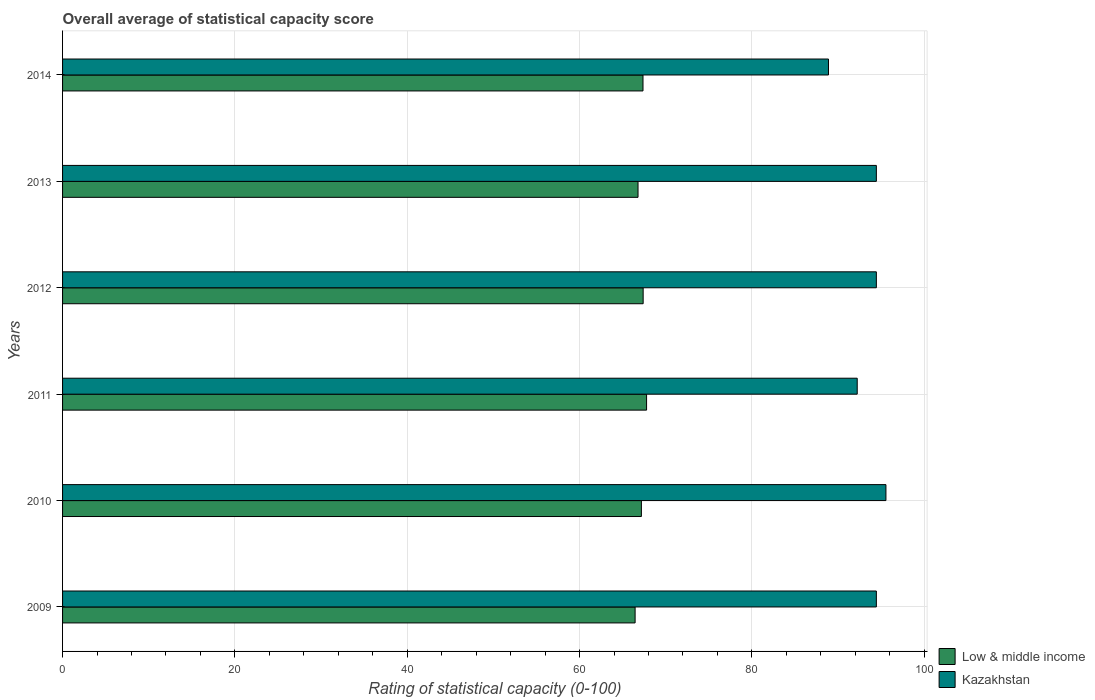How many different coloured bars are there?
Offer a terse response. 2. Are the number of bars per tick equal to the number of legend labels?
Give a very brief answer. Yes. Are the number of bars on each tick of the Y-axis equal?
Provide a succinct answer. Yes. How many bars are there on the 3rd tick from the top?
Ensure brevity in your answer.  2. How many bars are there on the 1st tick from the bottom?
Provide a succinct answer. 2. What is the label of the 2nd group of bars from the top?
Your response must be concise. 2013. In how many cases, is the number of bars for a given year not equal to the number of legend labels?
Give a very brief answer. 0. What is the rating of statistical capacity in Kazakhstan in 2014?
Ensure brevity in your answer.  88.89. Across all years, what is the maximum rating of statistical capacity in Low & middle income?
Make the answer very short. 67.78. Across all years, what is the minimum rating of statistical capacity in Kazakhstan?
Provide a short and direct response. 88.89. In which year was the rating of statistical capacity in Kazakhstan maximum?
Your answer should be compact. 2010. In which year was the rating of statistical capacity in Kazakhstan minimum?
Offer a terse response. 2014. What is the total rating of statistical capacity in Kazakhstan in the graph?
Make the answer very short. 560. What is the difference between the rating of statistical capacity in Kazakhstan in 2013 and that in 2014?
Offer a very short reply. 5.56. What is the difference between the rating of statistical capacity in Low & middle income in 2010 and the rating of statistical capacity in Kazakhstan in 2014?
Your answer should be compact. -21.71. What is the average rating of statistical capacity in Low & middle income per year?
Offer a terse response. 67.15. In the year 2009, what is the difference between the rating of statistical capacity in Low & middle income and rating of statistical capacity in Kazakhstan?
Give a very brief answer. -28. In how many years, is the rating of statistical capacity in Kazakhstan greater than 88 ?
Provide a succinct answer. 6. What is the ratio of the rating of statistical capacity in Low & middle income in 2011 to that in 2012?
Give a very brief answer. 1.01. Is the rating of statistical capacity in Kazakhstan in 2010 less than that in 2014?
Your answer should be compact. No. What is the difference between the highest and the second highest rating of statistical capacity in Low & middle income?
Keep it short and to the point. 0.4. What is the difference between the highest and the lowest rating of statistical capacity in Low & middle income?
Ensure brevity in your answer.  1.33. How many years are there in the graph?
Offer a very short reply. 6. What is the difference between two consecutive major ticks on the X-axis?
Your answer should be very brief. 20. Are the values on the major ticks of X-axis written in scientific E-notation?
Provide a short and direct response. No. Does the graph contain any zero values?
Ensure brevity in your answer.  No. Does the graph contain grids?
Ensure brevity in your answer.  Yes. How many legend labels are there?
Offer a very short reply. 2. What is the title of the graph?
Keep it short and to the point. Overall average of statistical capacity score. Does "China" appear as one of the legend labels in the graph?
Your answer should be compact. No. What is the label or title of the X-axis?
Your answer should be very brief. Rating of statistical capacity (0-100). What is the label or title of the Y-axis?
Offer a terse response. Years. What is the Rating of statistical capacity (0-100) in Low & middle income in 2009?
Your answer should be compact. 66.45. What is the Rating of statistical capacity (0-100) in Kazakhstan in 2009?
Offer a terse response. 94.44. What is the Rating of statistical capacity (0-100) of Low & middle income in 2010?
Your answer should be very brief. 67.18. What is the Rating of statistical capacity (0-100) of Kazakhstan in 2010?
Offer a terse response. 95.56. What is the Rating of statistical capacity (0-100) in Low & middle income in 2011?
Provide a succinct answer. 67.78. What is the Rating of statistical capacity (0-100) in Kazakhstan in 2011?
Offer a terse response. 92.22. What is the Rating of statistical capacity (0-100) of Low & middle income in 2012?
Your answer should be compact. 67.38. What is the Rating of statistical capacity (0-100) in Kazakhstan in 2012?
Your response must be concise. 94.44. What is the Rating of statistical capacity (0-100) in Low & middle income in 2013?
Offer a very short reply. 66.78. What is the Rating of statistical capacity (0-100) of Kazakhstan in 2013?
Your response must be concise. 94.44. What is the Rating of statistical capacity (0-100) in Low & middle income in 2014?
Keep it short and to the point. 67.36. What is the Rating of statistical capacity (0-100) of Kazakhstan in 2014?
Provide a short and direct response. 88.89. Across all years, what is the maximum Rating of statistical capacity (0-100) of Low & middle income?
Keep it short and to the point. 67.78. Across all years, what is the maximum Rating of statistical capacity (0-100) of Kazakhstan?
Make the answer very short. 95.56. Across all years, what is the minimum Rating of statistical capacity (0-100) of Low & middle income?
Keep it short and to the point. 66.45. Across all years, what is the minimum Rating of statistical capacity (0-100) in Kazakhstan?
Provide a succinct answer. 88.89. What is the total Rating of statistical capacity (0-100) in Low & middle income in the graph?
Ensure brevity in your answer.  402.93. What is the total Rating of statistical capacity (0-100) in Kazakhstan in the graph?
Ensure brevity in your answer.  560. What is the difference between the Rating of statistical capacity (0-100) in Low & middle income in 2009 and that in 2010?
Give a very brief answer. -0.73. What is the difference between the Rating of statistical capacity (0-100) in Kazakhstan in 2009 and that in 2010?
Ensure brevity in your answer.  -1.11. What is the difference between the Rating of statistical capacity (0-100) of Low & middle income in 2009 and that in 2011?
Provide a succinct answer. -1.33. What is the difference between the Rating of statistical capacity (0-100) of Kazakhstan in 2009 and that in 2011?
Give a very brief answer. 2.22. What is the difference between the Rating of statistical capacity (0-100) of Low & middle income in 2009 and that in 2012?
Provide a succinct answer. -0.93. What is the difference between the Rating of statistical capacity (0-100) of Kazakhstan in 2009 and that in 2012?
Give a very brief answer. 0. What is the difference between the Rating of statistical capacity (0-100) in Low & middle income in 2009 and that in 2013?
Provide a short and direct response. -0.34. What is the difference between the Rating of statistical capacity (0-100) in Kazakhstan in 2009 and that in 2013?
Make the answer very short. 0. What is the difference between the Rating of statistical capacity (0-100) in Low & middle income in 2009 and that in 2014?
Your answer should be compact. -0.92. What is the difference between the Rating of statistical capacity (0-100) of Kazakhstan in 2009 and that in 2014?
Give a very brief answer. 5.56. What is the difference between the Rating of statistical capacity (0-100) of Low & middle income in 2010 and that in 2011?
Offer a terse response. -0.6. What is the difference between the Rating of statistical capacity (0-100) of Kazakhstan in 2010 and that in 2011?
Your answer should be very brief. 3.33. What is the difference between the Rating of statistical capacity (0-100) of Low & middle income in 2010 and that in 2012?
Your response must be concise. -0.2. What is the difference between the Rating of statistical capacity (0-100) of Low & middle income in 2010 and that in 2013?
Give a very brief answer. 0.39. What is the difference between the Rating of statistical capacity (0-100) of Low & middle income in 2010 and that in 2014?
Offer a very short reply. -0.19. What is the difference between the Rating of statistical capacity (0-100) of Low & middle income in 2011 and that in 2012?
Your answer should be very brief. 0.4. What is the difference between the Rating of statistical capacity (0-100) in Kazakhstan in 2011 and that in 2012?
Offer a terse response. -2.22. What is the difference between the Rating of statistical capacity (0-100) of Low & middle income in 2011 and that in 2013?
Make the answer very short. 0.99. What is the difference between the Rating of statistical capacity (0-100) of Kazakhstan in 2011 and that in 2013?
Your response must be concise. -2.22. What is the difference between the Rating of statistical capacity (0-100) of Low & middle income in 2011 and that in 2014?
Offer a very short reply. 0.42. What is the difference between the Rating of statistical capacity (0-100) of Low & middle income in 2012 and that in 2013?
Ensure brevity in your answer.  0.59. What is the difference between the Rating of statistical capacity (0-100) in Kazakhstan in 2012 and that in 2013?
Your response must be concise. 0. What is the difference between the Rating of statistical capacity (0-100) in Low & middle income in 2012 and that in 2014?
Provide a succinct answer. 0.02. What is the difference between the Rating of statistical capacity (0-100) of Kazakhstan in 2012 and that in 2014?
Provide a short and direct response. 5.56. What is the difference between the Rating of statistical capacity (0-100) in Low & middle income in 2013 and that in 2014?
Provide a succinct answer. -0.58. What is the difference between the Rating of statistical capacity (0-100) of Kazakhstan in 2013 and that in 2014?
Give a very brief answer. 5.56. What is the difference between the Rating of statistical capacity (0-100) of Low & middle income in 2009 and the Rating of statistical capacity (0-100) of Kazakhstan in 2010?
Your response must be concise. -29.11. What is the difference between the Rating of statistical capacity (0-100) in Low & middle income in 2009 and the Rating of statistical capacity (0-100) in Kazakhstan in 2011?
Provide a short and direct response. -25.78. What is the difference between the Rating of statistical capacity (0-100) of Low & middle income in 2009 and the Rating of statistical capacity (0-100) of Kazakhstan in 2012?
Ensure brevity in your answer.  -28. What is the difference between the Rating of statistical capacity (0-100) of Low & middle income in 2009 and the Rating of statistical capacity (0-100) of Kazakhstan in 2013?
Your response must be concise. -28. What is the difference between the Rating of statistical capacity (0-100) in Low & middle income in 2009 and the Rating of statistical capacity (0-100) in Kazakhstan in 2014?
Offer a terse response. -22.44. What is the difference between the Rating of statistical capacity (0-100) of Low & middle income in 2010 and the Rating of statistical capacity (0-100) of Kazakhstan in 2011?
Give a very brief answer. -25.05. What is the difference between the Rating of statistical capacity (0-100) of Low & middle income in 2010 and the Rating of statistical capacity (0-100) of Kazakhstan in 2012?
Your answer should be compact. -27.27. What is the difference between the Rating of statistical capacity (0-100) of Low & middle income in 2010 and the Rating of statistical capacity (0-100) of Kazakhstan in 2013?
Your response must be concise. -27.27. What is the difference between the Rating of statistical capacity (0-100) of Low & middle income in 2010 and the Rating of statistical capacity (0-100) of Kazakhstan in 2014?
Your response must be concise. -21.71. What is the difference between the Rating of statistical capacity (0-100) in Low & middle income in 2011 and the Rating of statistical capacity (0-100) in Kazakhstan in 2012?
Give a very brief answer. -26.67. What is the difference between the Rating of statistical capacity (0-100) of Low & middle income in 2011 and the Rating of statistical capacity (0-100) of Kazakhstan in 2013?
Your response must be concise. -26.67. What is the difference between the Rating of statistical capacity (0-100) of Low & middle income in 2011 and the Rating of statistical capacity (0-100) of Kazakhstan in 2014?
Your answer should be very brief. -21.11. What is the difference between the Rating of statistical capacity (0-100) of Low & middle income in 2012 and the Rating of statistical capacity (0-100) of Kazakhstan in 2013?
Your answer should be compact. -27.07. What is the difference between the Rating of statistical capacity (0-100) in Low & middle income in 2012 and the Rating of statistical capacity (0-100) in Kazakhstan in 2014?
Your answer should be very brief. -21.51. What is the difference between the Rating of statistical capacity (0-100) in Low & middle income in 2013 and the Rating of statistical capacity (0-100) in Kazakhstan in 2014?
Offer a very short reply. -22.1. What is the average Rating of statistical capacity (0-100) of Low & middle income per year?
Provide a short and direct response. 67.15. What is the average Rating of statistical capacity (0-100) in Kazakhstan per year?
Provide a succinct answer. 93.33. In the year 2009, what is the difference between the Rating of statistical capacity (0-100) in Low & middle income and Rating of statistical capacity (0-100) in Kazakhstan?
Provide a succinct answer. -28. In the year 2010, what is the difference between the Rating of statistical capacity (0-100) of Low & middle income and Rating of statistical capacity (0-100) of Kazakhstan?
Your answer should be very brief. -28.38. In the year 2011, what is the difference between the Rating of statistical capacity (0-100) in Low & middle income and Rating of statistical capacity (0-100) in Kazakhstan?
Provide a succinct answer. -24.44. In the year 2012, what is the difference between the Rating of statistical capacity (0-100) of Low & middle income and Rating of statistical capacity (0-100) of Kazakhstan?
Your answer should be compact. -27.07. In the year 2013, what is the difference between the Rating of statistical capacity (0-100) of Low & middle income and Rating of statistical capacity (0-100) of Kazakhstan?
Make the answer very short. -27.66. In the year 2014, what is the difference between the Rating of statistical capacity (0-100) of Low & middle income and Rating of statistical capacity (0-100) of Kazakhstan?
Provide a succinct answer. -21.53. What is the ratio of the Rating of statistical capacity (0-100) in Kazakhstan in 2009 to that in 2010?
Offer a very short reply. 0.99. What is the ratio of the Rating of statistical capacity (0-100) of Low & middle income in 2009 to that in 2011?
Offer a terse response. 0.98. What is the ratio of the Rating of statistical capacity (0-100) in Kazakhstan in 2009 to that in 2011?
Your answer should be compact. 1.02. What is the ratio of the Rating of statistical capacity (0-100) in Low & middle income in 2009 to that in 2012?
Keep it short and to the point. 0.99. What is the ratio of the Rating of statistical capacity (0-100) in Kazakhstan in 2009 to that in 2012?
Offer a very short reply. 1. What is the ratio of the Rating of statistical capacity (0-100) in Low & middle income in 2009 to that in 2013?
Offer a very short reply. 0.99. What is the ratio of the Rating of statistical capacity (0-100) in Low & middle income in 2009 to that in 2014?
Your answer should be very brief. 0.99. What is the ratio of the Rating of statistical capacity (0-100) of Kazakhstan in 2009 to that in 2014?
Ensure brevity in your answer.  1.06. What is the ratio of the Rating of statistical capacity (0-100) of Low & middle income in 2010 to that in 2011?
Ensure brevity in your answer.  0.99. What is the ratio of the Rating of statistical capacity (0-100) of Kazakhstan in 2010 to that in 2011?
Offer a terse response. 1.04. What is the ratio of the Rating of statistical capacity (0-100) in Low & middle income in 2010 to that in 2012?
Provide a short and direct response. 1. What is the ratio of the Rating of statistical capacity (0-100) in Kazakhstan in 2010 to that in 2012?
Give a very brief answer. 1.01. What is the ratio of the Rating of statistical capacity (0-100) in Kazakhstan in 2010 to that in 2013?
Give a very brief answer. 1.01. What is the ratio of the Rating of statistical capacity (0-100) of Kazakhstan in 2010 to that in 2014?
Offer a very short reply. 1.07. What is the ratio of the Rating of statistical capacity (0-100) in Low & middle income in 2011 to that in 2012?
Your answer should be compact. 1.01. What is the ratio of the Rating of statistical capacity (0-100) of Kazakhstan in 2011 to that in 2012?
Your answer should be very brief. 0.98. What is the ratio of the Rating of statistical capacity (0-100) of Low & middle income in 2011 to that in 2013?
Make the answer very short. 1.01. What is the ratio of the Rating of statistical capacity (0-100) in Kazakhstan in 2011 to that in 2013?
Make the answer very short. 0.98. What is the ratio of the Rating of statistical capacity (0-100) in Kazakhstan in 2011 to that in 2014?
Offer a terse response. 1.04. What is the ratio of the Rating of statistical capacity (0-100) in Low & middle income in 2012 to that in 2013?
Provide a short and direct response. 1.01. What is the ratio of the Rating of statistical capacity (0-100) of Kazakhstan in 2012 to that in 2013?
Make the answer very short. 1. What is the ratio of the Rating of statistical capacity (0-100) of Low & middle income in 2012 to that in 2014?
Ensure brevity in your answer.  1. What is the ratio of the Rating of statistical capacity (0-100) of Kazakhstan in 2012 to that in 2014?
Offer a terse response. 1.06. What is the ratio of the Rating of statistical capacity (0-100) in Low & middle income in 2013 to that in 2014?
Provide a short and direct response. 0.99. What is the ratio of the Rating of statistical capacity (0-100) in Kazakhstan in 2013 to that in 2014?
Give a very brief answer. 1.06. What is the difference between the highest and the second highest Rating of statistical capacity (0-100) in Low & middle income?
Offer a terse response. 0.4. What is the difference between the highest and the lowest Rating of statistical capacity (0-100) of Low & middle income?
Make the answer very short. 1.33. 